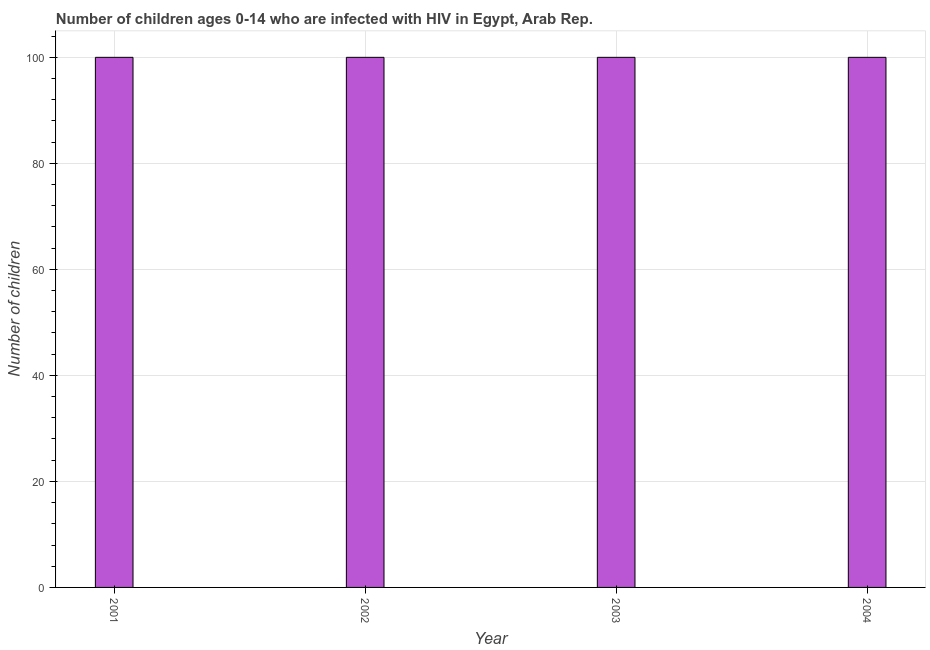What is the title of the graph?
Ensure brevity in your answer.  Number of children ages 0-14 who are infected with HIV in Egypt, Arab Rep. What is the label or title of the Y-axis?
Offer a very short reply. Number of children. Across all years, what is the maximum number of children living with hiv?
Provide a short and direct response. 100. Across all years, what is the minimum number of children living with hiv?
Your answer should be compact. 100. In which year was the number of children living with hiv maximum?
Your answer should be very brief. 2001. What is the average number of children living with hiv per year?
Offer a very short reply. 100. What is the median number of children living with hiv?
Provide a short and direct response. 100. What is the ratio of the number of children living with hiv in 2001 to that in 2004?
Your answer should be compact. 1. What is the difference between the highest and the second highest number of children living with hiv?
Ensure brevity in your answer.  0. Is the sum of the number of children living with hiv in 2002 and 2004 greater than the maximum number of children living with hiv across all years?
Offer a very short reply. Yes. What is the difference between the highest and the lowest number of children living with hiv?
Provide a short and direct response. 0. How many bars are there?
Provide a succinct answer. 4. How many years are there in the graph?
Provide a succinct answer. 4. What is the difference between the Number of children in 2001 and 2002?
Keep it short and to the point. 0. What is the difference between the Number of children in 2001 and 2004?
Give a very brief answer. 0. What is the difference between the Number of children in 2002 and 2004?
Provide a short and direct response. 0. What is the difference between the Number of children in 2003 and 2004?
Provide a succinct answer. 0. What is the ratio of the Number of children in 2001 to that in 2002?
Make the answer very short. 1. What is the ratio of the Number of children in 2001 to that in 2003?
Offer a terse response. 1. What is the ratio of the Number of children in 2002 to that in 2003?
Provide a short and direct response. 1. What is the ratio of the Number of children in 2002 to that in 2004?
Make the answer very short. 1. What is the ratio of the Number of children in 2003 to that in 2004?
Your response must be concise. 1. 